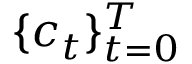<formula> <loc_0><loc_0><loc_500><loc_500>\{ c _ { t } \} _ { t = 0 } ^ { T }</formula> 